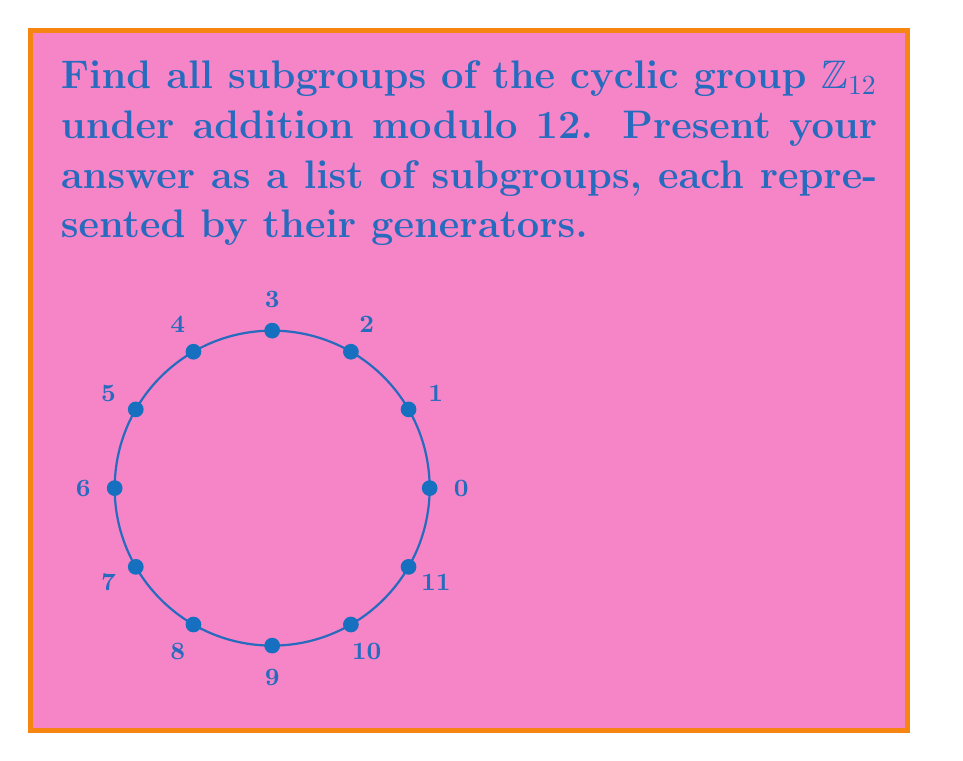Can you answer this question? To find all subgroups of $\mathbb{Z}_{12}$, we follow these steps:

1) Recall that in a cyclic group of order $n$, the subgroups are precisely the cyclic subgroups generated by the divisors of $n$.

2) The divisors of 12 are 1, 2, 3, 4, 6, and 12.

3) For each divisor $d$, we find the element $12/d$ in $\mathbb{Z}_{12}$, as this element generates a subgroup of order $d$.

4) Let's consider each divisor:

   - For $d=1$: $12/1 = 0$ generates $\langle 0 \rangle = \{0\}$
   - For $d=2$: $12/2 = 6$ generates $\langle 6 \rangle = \{0,6\}$
   - For $d=3$: $12/3 = 4$ generates $\langle 4 \rangle = \{0,4,8\}$
   - For $d=4$: $12/4 = 3$ generates $\langle 3 \rangle = \{0,3,6,9\}$
   - For $d=6$: $12/6 = 2$ generates $\langle 2 \rangle = \{0,2,4,6,8,10\}$
   - For $d=12$: $12/12 = 1$ generates $\langle 1 \rangle = \mathbb{Z}_{12}$

5) Note that $\langle 5 \rangle$ and $\langle 7 \rangle$ also generate the entire group $\mathbb{Z}_{12}$, as they are coprime to 12.

Therefore, all subgroups of $\mathbb{Z}_{12}$ are represented by these generators.
Answer: $\langle 0 \rangle, \langle 6 \rangle, \langle 4 \rangle, \langle 3 \rangle, \langle 2 \rangle, \langle 1 \rangle$ 